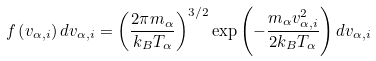<formula> <loc_0><loc_0><loc_500><loc_500>f \left ( v _ { \alpha , i } \right ) d v _ { \alpha , i } = \left ( \frac { 2 \pi m _ { \alpha } } { k _ { B } T _ { \alpha } } \right ) ^ { 3 / 2 } \exp \left ( - \frac { m _ { \alpha } v _ { \alpha , i } ^ { 2 } } { 2 k _ { B } T _ { \alpha } } \right ) d v _ { \alpha , i }</formula> 